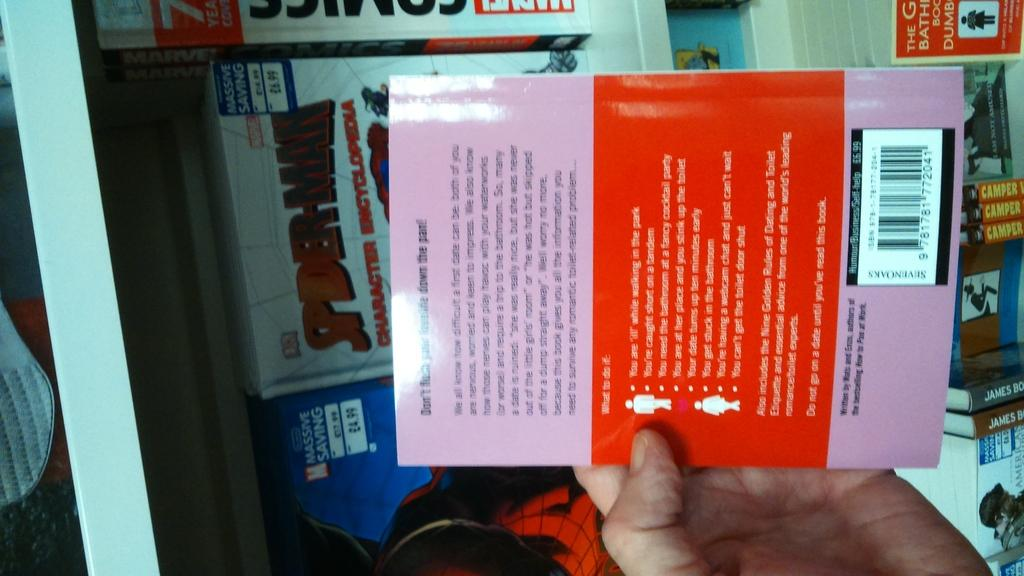Who or what is present in the image? There is a person in the image. What is the person holding in their hand? The person is holding a book in their hand. Are there any other books visible in the image? Yes, there are other books in the image. Can you describe any text visible in the image? There is text visible on the book that the person is holding. What type of feather can be seen on the guitar in the image? There is no guitar or feather present in the image. Can you compare the size of the person in the image to the size of a comparison object? There is no comparison object provided in the image, so it is not possible to make a size comparison. 